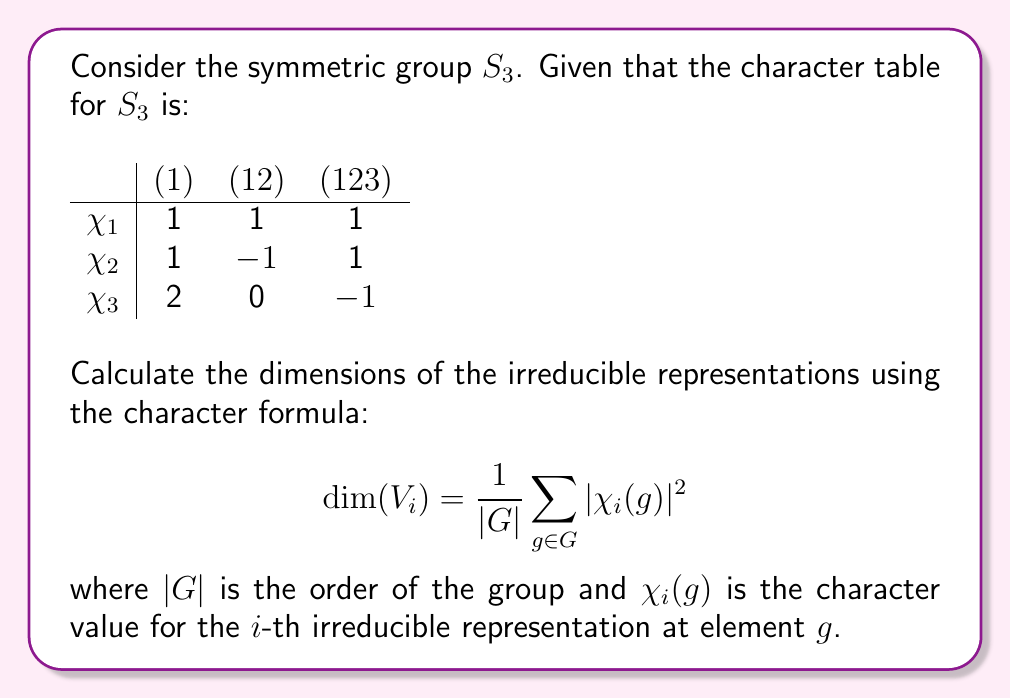Help me with this question. Let's approach this step-by-step for each irreducible representation:

1) For $\chi_1$:
   $$\dim(V_1) = \frac{1}{6} (|1|^2 \cdot 1 + |1|^2 \cdot 3 + |1|^2 \cdot 2)$$
   $$= \frac{1}{6} (1 \cdot 1 + 1 \cdot 3 + 1 \cdot 2) = \frac{1}{6} (6) = 1$$

2) For $\chi_2$:
   $$\dim(V_2) = \frac{1}{6} (|1|^2 \cdot 1 + |-1|^2 \cdot 3 + |1|^2 \cdot 2)$$
   $$= \frac{1}{6} (1 \cdot 1 + 1 \cdot 3 + 1 \cdot 2) = \frac{1}{6} (6) = 1$$

3) For $\chi_3$:
   $$\dim(V_3) = \frac{1}{6} (|2|^2 \cdot 1 + |0|^2 \cdot 3 + |-1|^2 \cdot 2)$$
   $$= \frac{1}{6} (4 \cdot 1 + 0 \cdot 3 + 1 \cdot 2) = \frac{1}{6} (6) = 2$$

Note that we're using the fact that $S_3$ has 6 elements: 1 element of order 1, 3 elements of order 2, and 2 elements of order 3.

This method provides a way to verify the dimensions directly from the character table, which could be particularly useful in e-learning environments where traditional classroom interactions might be limited.
Answer: $\dim(V_1) = 1$, $\dim(V_2) = 1$, $\dim(V_3) = 2$ 